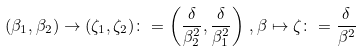Convert formula to latex. <formula><loc_0><loc_0><loc_500><loc_500>( \beta _ { 1 } , \beta _ { 2 } ) \to ( \zeta _ { 1 } , \zeta _ { 2 } ) \colon = \left ( \frac { \delta } { \beta _ { 2 } ^ { 2 } } , \frac { \delta } { \beta _ { 1 } ^ { 2 } } \right ) \, , \beta \mapsto \zeta \colon = \frac { \delta } { \beta ^ { 2 } }</formula> 